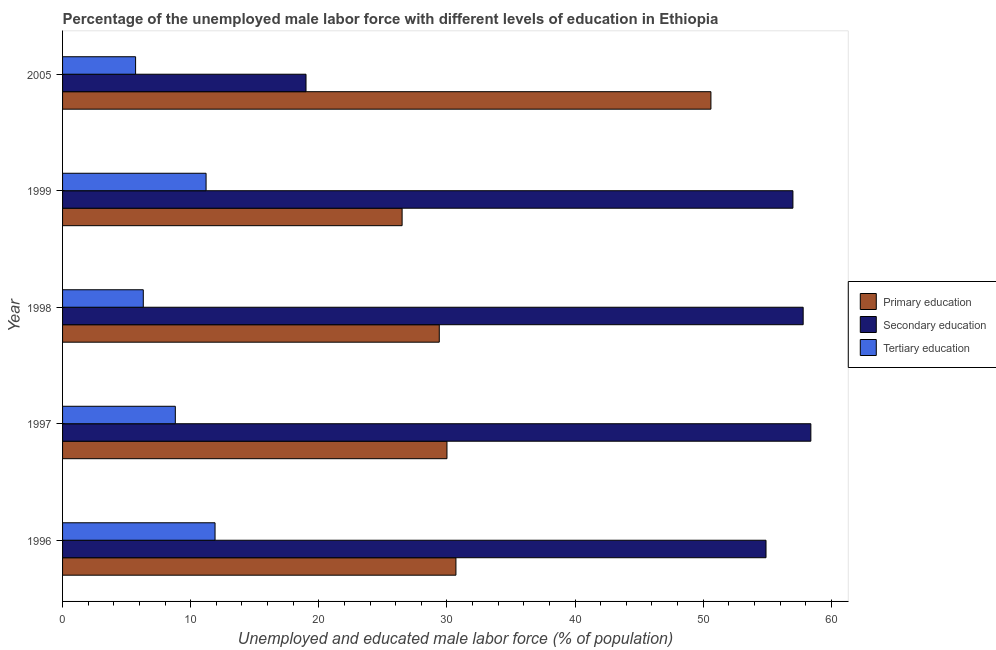How many different coloured bars are there?
Offer a very short reply. 3. How many groups of bars are there?
Provide a short and direct response. 5. In how many cases, is the number of bars for a given year not equal to the number of legend labels?
Make the answer very short. 0. What is the percentage of male labor force who received tertiary education in 1999?
Keep it short and to the point. 11.2. Across all years, what is the maximum percentage of male labor force who received tertiary education?
Ensure brevity in your answer.  11.9. Across all years, what is the minimum percentage of male labor force who received primary education?
Provide a succinct answer. 26.5. In which year was the percentage of male labor force who received secondary education maximum?
Ensure brevity in your answer.  1997. In which year was the percentage of male labor force who received secondary education minimum?
Provide a short and direct response. 2005. What is the total percentage of male labor force who received tertiary education in the graph?
Offer a very short reply. 43.9. What is the difference between the percentage of male labor force who received primary education in 1997 and the percentage of male labor force who received secondary education in 1996?
Keep it short and to the point. -24.9. What is the average percentage of male labor force who received primary education per year?
Offer a terse response. 33.44. In the year 1999, what is the difference between the percentage of male labor force who received secondary education and percentage of male labor force who received tertiary education?
Provide a short and direct response. 45.8. What is the ratio of the percentage of male labor force who received secondary education in 1997 to that in 1999?
Provide a succinct answer. 1.02. Is the percentage of male labor force who received primary education in 1999 less than that in 2005?
Offer a very short reply. Yes. Is the difference between the percentage of male labor force who received tertiary education in 1998 and 2005 greater than the difference between the percentage of male labor force who received primary education in 1998 and 2005?
Give a very brief answer. Yes. What is the difference between the highest and the lowest percentage of male labor force who received secondary education?
Give a very brief answer. 39.4. In how many years, is the percentage of male labor force who received primary education greater than the average percentage of male labor force who received primary education taken over all years?
Give a very brief answer. 1. What does the 1st bar from the top in 1998 represents?
Provide a short and direct response. Tertiary education. What does the 3rd bar from the bottom in 1998 represents?
Your answer should be very brief. Tertiary education. Is it the case that in every year, the sum of the percentage of male labor force who received primary education and percentage of male labor force who received secondary education is greater than the percentage of male labor force who received tertiary education?
Offer a terse response. Yes. Are all the bars in the graph horizontal?
Offer a very short reply. Yes. Does the graph contain any zero values?
Keep it short and to the point. No. What is the title of the graph?
Provide a succinct answer. Percentage of the unemployed male labor force with different levels of education in Ethiopia. What is the label or title of the X-axis?
Your answer should be compact. Unemployed and educated male labor force (% of population). What is the label or title of the Y-axis?
Provide a succinct answer. Year. What is the Unemployed and educated male labor force (% of population) in Primary education in 1996?
Provide a succinct answer. 30.7. What is the Unemployed and educated male labor force (% of population) in Secondary education in 1996?
Your answer should be very brief. 54.9. What is the Unemployed and educated male labor force (% of population) in Tertiary education in 1996?
Ensure brevity in your answer.  11.9. What is the Unemployed and educated male labor force (% of population) in Secondary education in 1997?
Offer a very short reply. 58.4. What is the Unemployed and educated male labor force (% of population) in Tertiary education in 1997?
Offer a terse response. 8.8. What is the Unemployed and educated male labor force (% of population) of Primary education in 1998?
Keep it short and to the point. 29.4. What is the Unemployed and educated male labor force (% of population) in Secondary education in 1998?
Give a very brief answer. 57.8. What is the Unemployed and educated male labor force (% of population) of Tertiary education in 1998?
Your response must be concise. 6.3. What is the Unemployed and educated male labor force (% of population) in Tertiary education in 1999?
Provide a short and direct response. 11.2. What is the Unemployed and educated male labor force (% of population) of Primary education in 2005?
Provide a short and direct response. 50.6. What is the Unemployed and educated male labor force (% of population) of Secondary education in 2005?
Your answer should be compact. 19. What is the Unemployed and educated male labor force (% of population) of Tertiary education in 2005?
Ensure brevity in your answer.  5.7. Across all years, what is the maximum Unemployed and educated male labor force (% of population) of Primary education?
Offer a terse response. 50.6. Across all years, what is the maximum Unemployed and educated male labor force (% of population) in Secondary education?
Provide a short and direct response. 58.4. Across all years, what is the maximum Unemployed and educated male labor force (% of population) in Tertiary education?
Ensure brevity in your answer.  11.9. Across all years, what is the minimum Unemployed and educated male labor force (% of population) in Tertiary education?
Make the answer very short. 5.7. What is the total Unemployed and educated male labor force (% of population) of Primary education in the graph?
Your response must be concise. 167.2. What is the total Unemployed and educated male labor force (% of population) in Secondary education in the graph?
Your answer should be very brief. 247.1. What is the total Unemployed and educated male labor force (% of population) in Tertiary education in the graph?
Provide a short and direct response. 43.9. What is the difference between the Unemployed and educated male labor force (% of population) of Primary education in 1996 and that in 1997?
Offer a very short reply. 0.7. What is the difference between the Unemployed and educated male labor force (% of population) of Tertiary education in 1996 and that in 1997?
Your response must be concise. 3.1. What is the difference between the Unemployed and educated male labor force (% of population) of Primary education in 1996 and that in 1999?
Give a very brief answer. 4.2. What is the difference between the Unemployed and educated male labor force (% of population) in Primary education in 1996 and that in 2005?
Offer a very short reply. -19.9. What is the difference between the Unemployed and educated male labor force (% of population) of Secondary education in 1996 and that in 2005?
Give a very brief answer. 35.9. What is the difference between the Unemployed and educated male labor force (% of population) in Tertiary education in 1996 and that in 2005?
Provide a succinct answer. 6.2. What is the difference between the Unemployed and educated male labor force (% of population) in Tertiary education in 1997 and that in 1998?
Ensure brevity in your answer.  2.5. What is the difference between the Unemployed and educated male labor force (% of population) of Tertiary education in 1997 and that in 1999?
Provide a succinct answer. -2.4. What is the difference between the Unemployed and educated male labor force (% of population) of Primary education in 1997 and that in 2005?
Offer a very short reply. -20.6. What is the difference between the Unemployed and educated male labor force (% of population) in Secondary education in 1997 and that in 2005?
Ensure brevity in your answer.  39.4. What is the difference between the Unemployed and educated male labor force (% of population) of Tertiary education in 1997 and that in 2005?
Offer a very short reply. 3.1. What is the difference between the Unemployed and educated male labor force (% of population) of Primary education in 1998 and that in 2005?
Your answer should be compact. -21.2. What is the difference between the Unemployed and educated male labor force (% of population) in Secondary education in 1998 and that in 2005?
Provide a short and direct response. 38.8. What is the difference between the Unemployed and educated male labor force (% of population) in Tertiary education in 1998 and that in 2005?
Give a very brief answer. 0.6. What is the difference between the Unemployed and educated male labor force (% of population) of Primary education in 1999 and that in 2005?
Give a very brief answer. -24.1. What is the difference between the Unemployed and educated male labor force (% of population) in Secondary education in 1999 and that in 2005?
Make the answer very short. 38. What is the difference between the Unemployed and educated male labor force (% of population) in Primary education in 1996 and the Unemployed and educated male labor force (% of population) in Secondary education in 1997?
Your answer should be compact. -27.7. What is the difference between the Unemployed and educated male labor force (% of population) of Primary education in 1996 and the Unemployed and educated male labor force (% of population) of Tertiary education in 1997?
Your answer should be compact. 21.9. What is the difference between the Unemployed and educated male labor force (% of population) in Secondary education in 1996 and the Unemployed and educated male labor force (% of population) in Tertiary education in 1997?
Your response must be concise. 46.1. What is the difference between the Unemployed and educated male labor force (% of population) of Primary education in 1996 and the Unemployed and educated male labor force (% of population) of Secondary education in 1998?
Ensure brevity in your answer.  -27.1. What is the difference between the Unemployed and educated male labor force (% of population) of Primary education in 1996 and the Unemployed and educated male labor force (% of population) of Tertiary education in 1998?
Give a very brief answer. 24.4. What is the difference between the Unemployed and educated male labor force (% of population) of Secondary education in 1996 and the Unemployed and educated male labor force (% of population) of Tertiary education in 1998?
Ensure brevity in your answer.  48.6. What is the difference between the Unemployed and educated male labor force (% of population) in Primary education in 1996 and the Unemployed and educated male labor force (% of population) in Secondary education in 1999?
Your answer should be compact. -26.3. What is the difference between the Unemployed and educated male labor force (% of population) of Secondary education in 1996 and the Unemployed and educated male labor force (% of population) of Tertiary education in 1999?
Offer a very short reply. 43.7. What is the difference between the Unemployed and educated male labor force (% of population) in Primary education in 1996 and the Unemployed and educated male labor force (% of population) in Tertiary education in 2005?
Ensure brevity in your answer.  25. What is the difference between the Unemployed and educated male labor force (% of population) of Secondary education in 1996 and the Unemployed and educated male labor force (% of population) of Tertiary education in 2005?
Provide a short and direct response. 49.2. What is the difference between the Unemployed and educated male labor force (% of population) in Primary education in 1997 and the Unemployed and educated male labor force (% of population) in Secondary education in 1998?
Offer a very short reply. -27.8. What is the difference between the Unemployed and educated male labor force (% of population) of Primary education in 1997 and the Unemployed and educated male labor force (% of population) of Tertiary education in 1998?
Keep it short and to the point. 23.7. What is the difference between the Unemployed and educated male labor force (% of population) of Secondary education in 1997 and the Unemployed and educated male labor force (% of population) of Tertiary education in 1998?
Your response must be concise. 52.1. What is the difference between the Unemployed and educated male labor force (% of population) in Primary education in 1997 and the Unemployed and educated male labor force (% of population) in Secondary education in 1999?
Your answer should be very brief. -27. What is the difference between the Unemployed and educated male labor force (% of population) of Secondary education in 1997 and the Unemployed and educated male labor force (% of population) of Tertiary education in 1999?
Give a very brief answer. 47.2. What is the difference between the Unemployed and educated male labor force (% of population) in Primary education in 1997 and the Unemployed and educated male labor force (% of population) in Secondary education in 2005?
Give a very brief answer. 11. What is the difference between the Unemployed and educated male labor force (% of population) of Primary education in 1997 and the Unemployed and educated male labor force (% of population) of Tertiary education in 2005?
Make the answer very short. 24.3. What is the difference between the Unemployed and educated male labor force (% of population) of Secondary education in 1997 and the Unemployed and educated male labor force (% of population) of Tertiary education in 2005?
Your response must be concise. 52.7. What is the difference between the Unemployed and educated male labor force (% of population) in Primary education in 1998 and the Unemployed and educated male labor force (% of population) in Secondary education in 1999?
Keep it short and to the point. -27.6. What is the difference between the Unemployed and educated male labor force (% of population) of Primary education in 1998 and the Unemployed and educated male labor force (% of population) of Tertiary education in 1999?
Ensure brevity in your answer.  18.2. What is the difference between the Unemployed and educated male labor force (% of population) of Secondary education in 1998 and the Unemployed and educated male labor force (% of population) of Tertiary education in 1999?
Offer a terse response. 46.6. What is the difference between the Unemployed and educated male labor force (% of population) in Primary education in 1998 and the Unemployed and educated male labor force (% of population) in Secondary education in 2005?
Your answer should be very brief. 10.4. What is the difference between the Unemployed and educated male labor force (% of population) of Primary education in 1998 and the Unemployed and educated male labor force (% of population) of Tertiary education in 2005?
Your answer should be very brief. 23.7. What is the difference between the Unemployed and educated male labor force (% of population) in Secondary education in 1998 and the Unemployed and educated male labor force (% of population) in Tertiary education in 2005?
Offer a very short reply. 52.1. What is the difference between the Unemployed and educated male labor force (% of population) in Primary education in 1999 and the Unemployed and educated male labor force (% of population) in Tertiary education in 2005?
Provide a short and direct response. 20.8. What is the difference between the Unemployed and educated male labor force (% of population) of Secondary education in 1999 and the Unemployed and educated male labor force (% of population) of Tertiary education in 2005?
Offer a very short reply. 51.3. What is the average Unemployed and educated male labor force (% of population) in Primary education per year?
Your answer should be compact. 33.44. What is the average Unemployed and educated male labor force (% of population) in Secondary education per year?
Ensure brevity in your answer.  49.42. What is the average Unemployed and educated male labor force (% of population) in Tertiary education per year?
Ensure brevity in your answer.  8.78. In the year 1996, what is the difference between the Unemployed and educated male labor force (% of population) in Primary education and Unemployed and educated male labor force (% of population) in Secondary education?
Make the answer very short. -24.2. In the year 1996, what is the difference between the Unemployed and educated male labor force (% of population) in Primary education and Unemployed and educated male labor force (% of population) in Tertiary education?
Your answer should be very brief. 18.8. In the year 1996, what is the difference between the Unemployed and educated male labor force (% of population) in Secondary education and Unemployed and educated male labor force (% of population) in Tertiary education?
Offer a terse response. 43. In the year 1997, what is the difference between the Unemployed and educated male labor force (% of population) in Primary education and Unemployed and educated male labor force (% of population) in Secondary education?
Keep it short and to the point. -28.4. In the year 1997, what is the difference between the Unemployed and educated male labor force (% of population) in Primary education and Unemployed and educated male labor force (% of population) in Tertiary education?
Give a very brief answer. 21.2. In the year 1997, what is the difference between the Unemployed and educated male labor force (% of population) in Secondary education and Unemployed and educated male labor force (% of population) in Tertiary education?
Ensure brevity in your answer.  49.6. In the year 1998, what is the difference between the Unemployed and educated male labor force (% of population) of Primary education and Unemployed and educated male labor force (% of population) of Secondary education?
Offer a very short reply. -28.4. In the year 1998, what is the difference between the Unemployed and educated male labor force (% of population) in Primary education and Unemployed and educated male labor force (% of population) in Tertiary education?
Your answer should be compact. 23.1. In the year 1998, what is the difference between the Unemployed and educated male labor force (% of population) of Secondary education and Unemployed and educated male labor force (% of population) of Tertiary education?
Your response must be concise. 51.5. In the year 1999, what is the difference between the Unemployed and educated male labor force (% of population) of Primary education and Unemployed and educated male labor force (% of population) of Secondary education?
Offer a very short reply. -30.5. In the year 1999, what is the difference between the Unemployed and educated male labor force (% of population) in Primary education and Unemployed and educated male labor force (% of population) in Tertiary education?
Give a very brief answer. 15.3. In the year 1999, what is the difference between the Unemployed and educated male labor force (% of population) in Secondary education and Unemployed and educated male labor force (% of population) in Tertiary education?
Offer a terse response. 45.8. In the year 2005, what is the difference between the Unemployed and educated male labor force (% of population) of Primary education and Unemployed and educated male labor force (% of population) of Secondary education?
Give a very brief answer. 31.6. In the year 2005, what is the difference between the Unemployed and educated male labor force (% of population) in Primary education and Unemployed and educated male labor force (% of population) in Tertiary education?
Make the answer very short. 44.9. What is the ratio of the Unemployed and educated male labor force (% of population) of Primary education in 1996 to that in 1997?
Your answer should be compact. 1.02. What is the ratio of the Unemployed and educated male labor force (% of population) in Secondary education in 1996 to that in 1997?
Your answer should be compact. 0.94. What is the ratio of the Unemployed and educated male labor force (% of population) in Tertiary education in 1996 to that in 1997?
Provide a succinct answer. 1.35. What is the ratio of the Unemployed and educated male labor force (% of population) in Primary education in 1996 to that in 1998?
Provide a succinct answer. 1.04. What is the ratio of the Unemployed and educated male labor force (% of population) of Secondary education in 1996 to that in 1998?
Offer a terse response. 0.95. What is the ratio of the Unemployed and educated male labor force (% of population) of Tertiary education in 1996 to that in 1998?
Keep it short and to the point. 1.89. What is the ratio of the Unemployed and educated male labor force (% of population) of Primary education in 1996 to that in 1999?
Your response must be concise. 1.16. What is the ratio of the Unemployed and educated male labor force (% of population) in Secondary education in 1996 to that in 1999?
Your response must be concise. 0.96. What is the ratio of the Unemployed and educated male labor force (% of population) of Tertiary education in 1996 to that in 1999?
Make the answer very short. 1.06. What is the ratio of the Unemployed and educated male labor force (% of population) in Primary education in 1996 to that in 2005?
Keep it short and to the point. 0.61. What is the ratio of the Unemployed and educated male labor force (% of population) in Secondary education in 1996 to that in 2005?
Your response must be concise. 2.89. What is the ratio of the Unemployed and educated male labor force (% of population) of Tertiary education in 1996 to that in 2005?
Give a very brief answer. 2.09. What is the ratio of the Unemployed and educated male labor force (% of population) of Primary education in 1997 to that in 1998?
Provide a short and direct response. 1.02. What is the ratio of the Unemployed and educated male labor force (% of population) in Secondary education in 1997 to that in 1998?
Give a very brief answer. 1.01. What is the ratio of the Unemployed and educated male labor force (% of population) in Tertiary education in 1997 to that in 1998?
Keep it short and to the point. 1.4. What is the ratio of the Unemployed and educated male labor force (% of population) in Primary education in 1997 to that in 1999?
Offer a terse response. 1.13. What is the ratio of the Unemployed and educated male labor force (% of population) of Secondary education in 1997 to that in 1999?
Ensure brevity in your answer.  1.02. What is the ratio of the Unemployed and educated male labor force (% of population) in Tertiary education in 1997 to that in 1999?
Your answer should be very brief. 0.79. What is the ratio of the Unemployed and educated male labor force (% of population) of Primary education in 1997 to that in 2005?
Offer a very short reply. 0.59. What is the ratio of the Unemployed and educated male labor force (% of population) in Secondary education in 1997 to that in 2005?
Give a very brief answer. 3.07. What is the ratio of the Unemployed and educated male labor force (% of population) of Tertiary education in 1997 to that in 2005?
Your response must be concise. 1.54. What is the ratio of the Unemployed and educated male labor force (% of population) of Primary education in 1998 to that in 1999?
Your response must be concise. 1.11. What is the ratio of the Unemployed and educated male labor force (% of population) in Secondary education in 1998 to that in 1999?
Make the answer very short. 1.01. What is the ratio of the Unemployed and educated male labor force (% of population) of Tertiary education in 1998 to that in 1999?
Offer a terse response. 0.56. What is the ratio of the Unemployed and educated male labor force (% of population) in Primary education in 1998 to that in 2005?
Ensure brevity in your answer.  0.58. What is the ratio of the Unemployed and educated male labor force (% of population) of Secondary education in 1998 to that in 2005?
Ensure brevity in your answer.  3.04. What is the ratio of the Unemployed and educated male labor force (% of population) in Tertiary education in 1998 to that in 2005?
Provide a succinct answer. 1.11. What is the ratio of the Unemployed and educated male labor force (% of population) of Primary education in 1999 to that in 2005?
Ensure brevity in your answer.  0.52. What is the ratio of the Unemployed and educated male labor force (% of population) of Secondary education in 1999 to that in 2005?
Keep it short and to the point. 3. What is the ratio of the Unemployed and educated male labor force (% of population) in Tertiary education in 1999 to that in 2005?
Make the answer very short. 1.96. What is the difference between the highest and the second highest Unemployed and educated male labor force (% of population) of Primary education?
Offer a very short reply. 19.9. What is the difference between the highest and the lowest Unemployed and educated male labor force (% of population) of Primary education?
Offer a very short reply. 24.1. What is the difference between the highest and the lowest Unemployed and educated male labor force (% of population) in Secondary education?
Your answer should be very brief. 39.4. What is the difference between the highest and the lowest Unemployed and educated male labor force (% of population) in Tertiary education?
Offer a terse response. 6.2. 